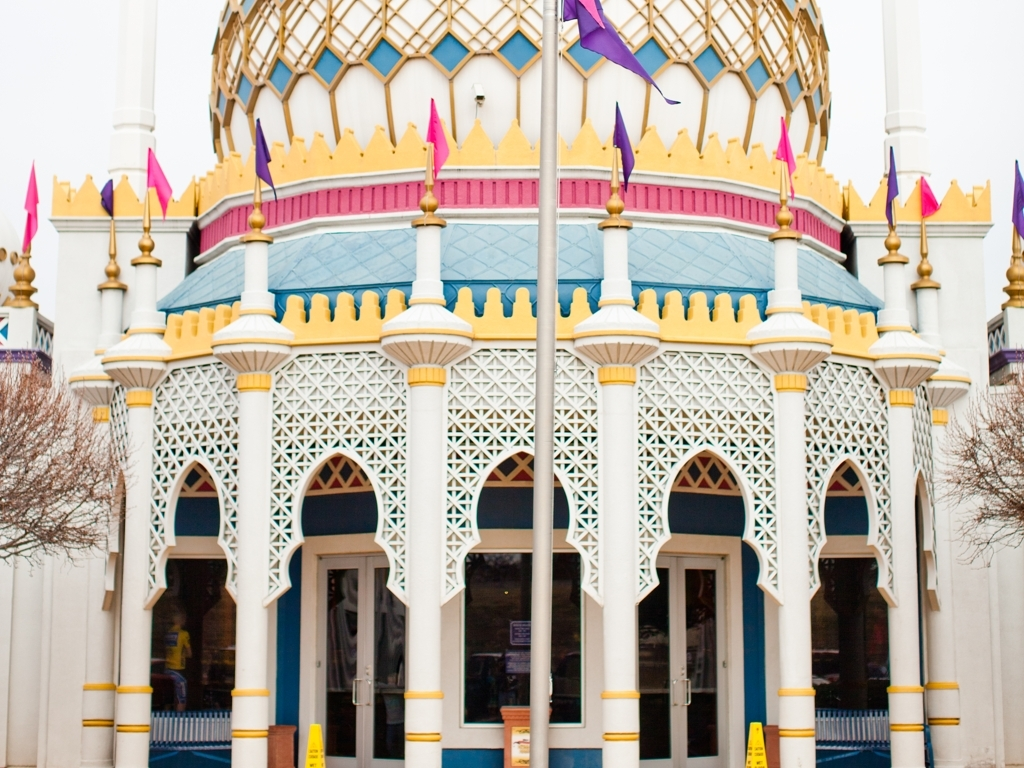Can you tell what time of day this photo was taken? The flat lighting and lack of shadows suggest this photo was taken on an overcast day, making it difficult to determine the exact time. However, the absence of strong shadows hints at midday. 